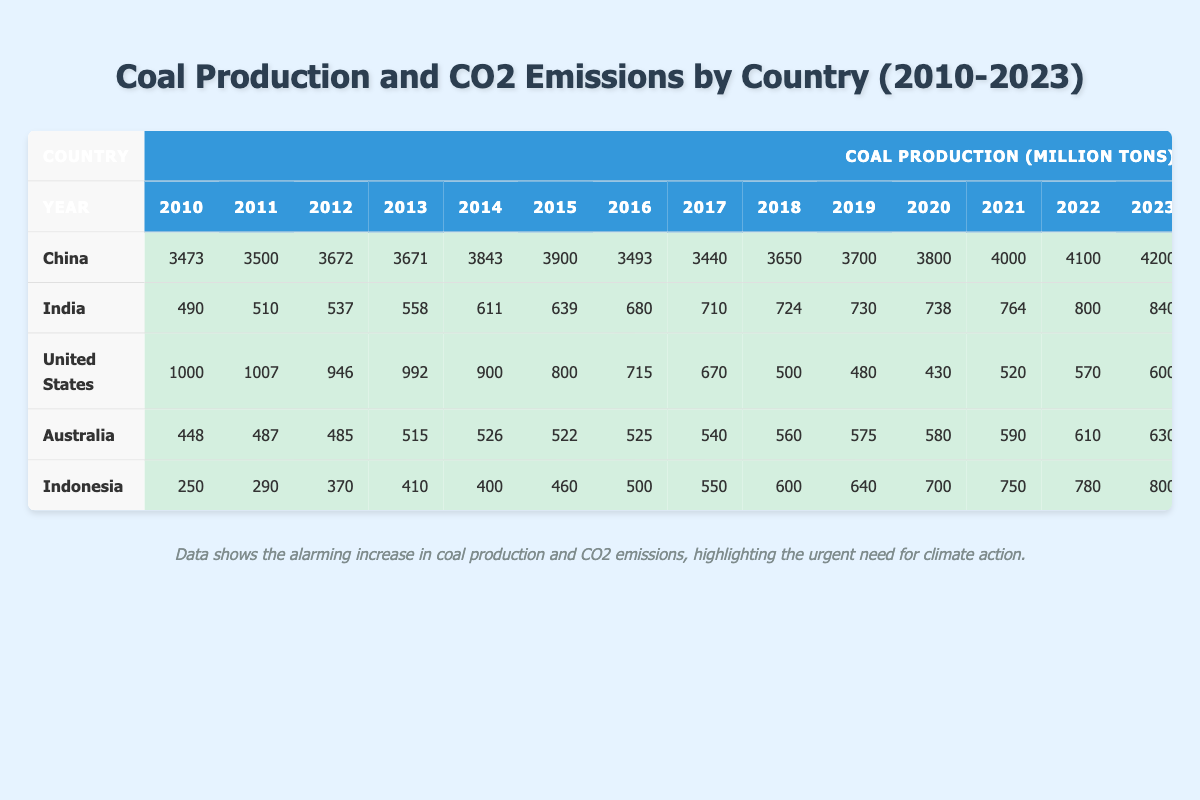What was the coal production of China in 2010? Referring to the table, the coal production of China in 2010 is listed as 3473 million tons.
Answer: 3473 million tons Which country had the highest CO2 emissions in 2023? By checking the emissions figures for 2023 across the countries, China has the highest CO2 emissions at 12500 million tons.
Answer: China What was the average annual coal production of India from 2010 to 2023? To calculate the average, first, sum India's coal production from 2010 (490) to 2023 (840): 490 + 510 + 537 + 558 + 611 + 639 + 680 + 710 + 724 + 730 + 738 + 764 + 800 + 840 = 10000. Since there are 14 years, divide this sum by 14: 10000 / 14 = approximately 714.29 million tons.
Answer: Approximately 714.29 million tons Did the coal production of the United States increase or decrease from 2010 to 2023? Looking at the data, the coal production in 2010 was 1000 million tons and in 2023 it was 600 million tons, indicating a decrease over the years.
Answer: Decrease What was the total CO2 emissions of Australia from 2010 to 2023? To find the total, sum Australia's CO2 emissions from 2010 (270) to 2023 (320): 270 + 290 + 290 + 295 + 300 + 290 + 285 + 280 + 290 + 295 + 300 + 310 + 315 + 320 = 3875 million tons.
Answer: 3875 million tons Which country shows a consistent increase in coal production from 2010 to 2023? By analyzing the coal production data for each year, India shows a consistent increase from 490 million tons in 2010 to 840 million tons in 2023.
Answer: India What is the difference in CO2 emissions between China and India in 2022? In 2022, China's CO2 emissions are 12000 million tons and India's are 3200 million tons. The difference is calculated as 12000 - 3200 = 8800 million tons.
Answer: 8800 million tons Which country had the highest increase in CO2 emissions from 2010 to 2023? Calculate the annual increase by subtracting the CO2 emissions in 2010 from those in 2023: For China, it's 12500 - 8253 = 4247 million tons, for India, it's 3500 - 1890 = 1610 million tons, for the United States, it's 1150 - 1846 = -696 million tons (decrease), and for Indonesia, it's 410 - 115 = 295 million tons. China had the highest increase.
Answer: China How much did Australia reduce its coal production from 2010 to 2018? In 2010, Australia's coal production was 448 million tons, and in 2018 it was 560 million tons. The production actually increased, which means no reduction occurred.
Answer: No reduction What was the percentage increase in coal production for Indonesia from 2010 to 2023? Initially, Indonesia produced 250 million tons in 2010 and increased to 800 million tons by 2023. The increase is calculated as (800 - 250) / 250 * 100 = 220%.
Answer: 220% 